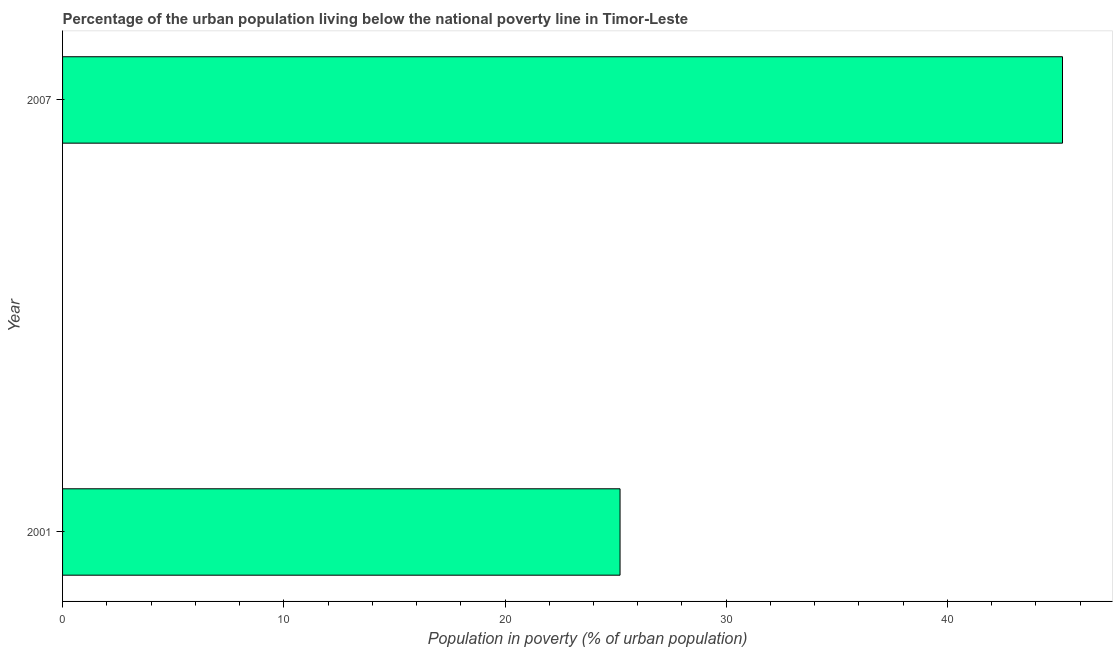What is the title of the graph?
Your answer should be compact. Percentage of the urban population living below the national poverty line in Timor-Leste. What is the label or title of the X-axis?
Give a very brief answer. Population in poverty (% of urban population). What is the label or title of the Y-axis?
Your answer should be compact. Year. What is the percentage of urban population living below poverty line in 2007?
Give a very brief answer. 45.2. Across all years, what is the maximum percentage of urban population living below poverty line?
Provide a short and direct response. 45.2. Across all years, what is the minimum percentage of urban population living below poverty line?
Provide a succinct answer. 25.2. In which year was the percentage of urban population living below poverty line maximum?
Make the answer very short. 2007. In which year was the percentage of urban population living below poverty line minimum?
Make the answer very short. 2001. What is the sum of the percentage of urban population living below poverty line?
Offer a terse response. 70.4. What is the average percentage of urban population living below poverty line per year?
Your answer should be very brief. 35.2. What is the median percentage of urban population living below poverty line?
Make the answer very short. 35.2. What is the ratio of the percentage of urban population living below poverty line in 2001 to that in 2007?
Make the answer very short. 0.56. Are all the bars in the graph horizontal?
Offer a very short reply. Yes. Are the values on the major ticks of X-axis written in scientific E-notation?
Provide a succinct answer. No. What is the Population in poverty (% of urban population) in 2001?
Offer a terse response. 25.2. What is the Population in poverty (% of urban population) of 2007?
Ensure brevity in your answer.  45.2. What is the ratio of the Population in poverty (% of urban population) in 2001 to that in 2007?
Your answer should be very brief. 0.56. 